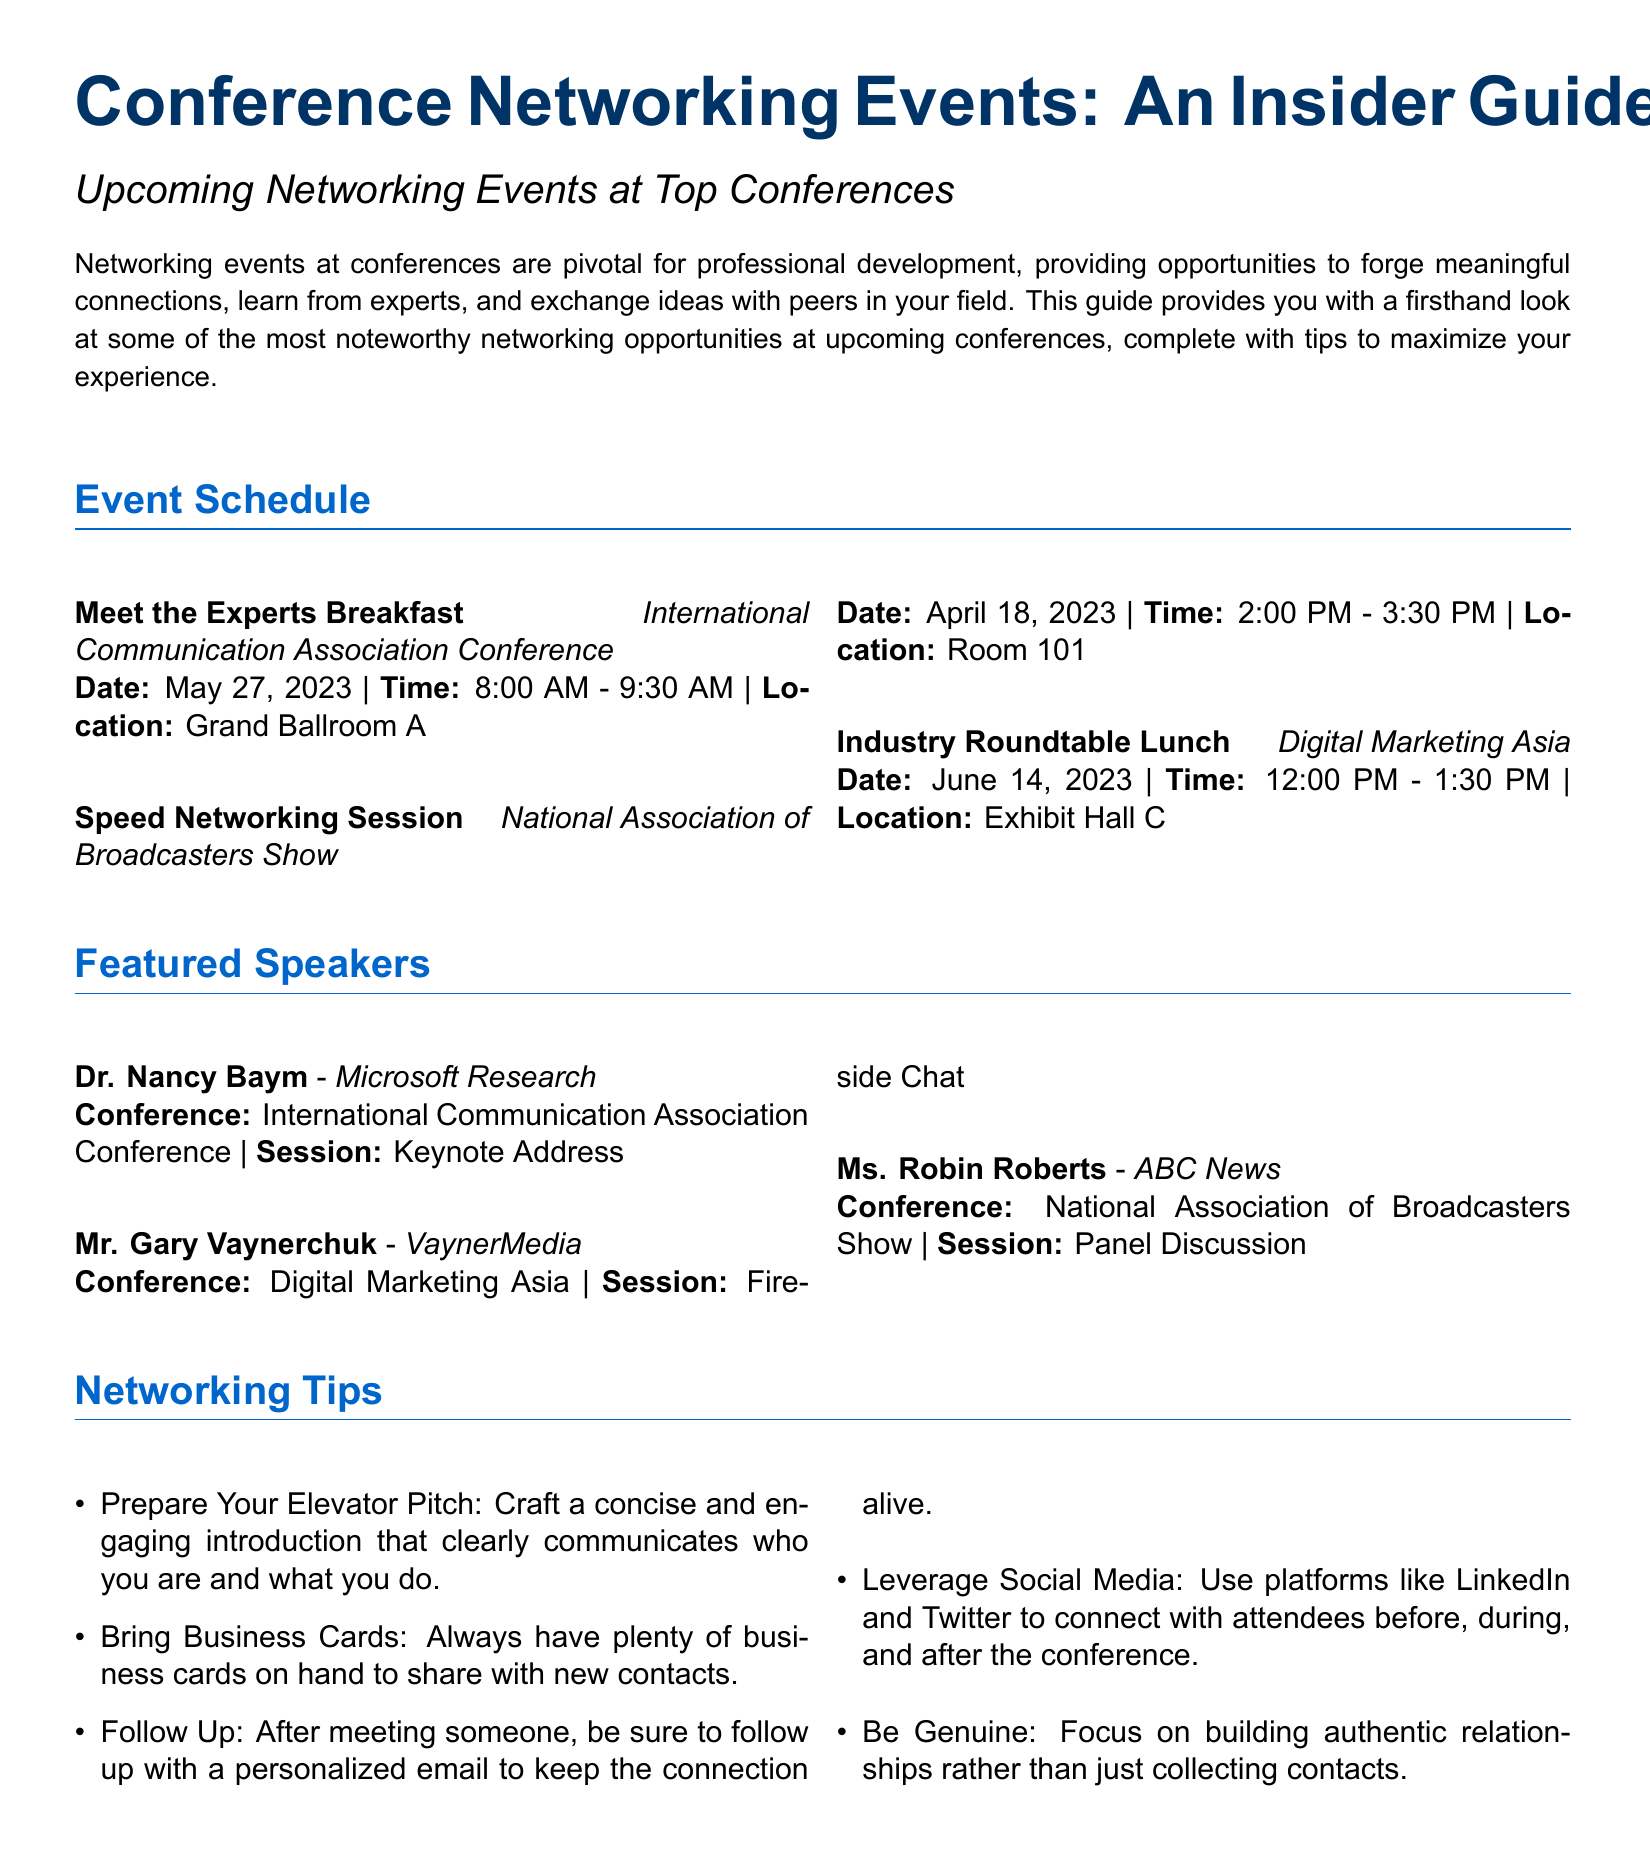What is the date of the Meet the Experts Breakfast? The date for the event is specifically mentioned in the event schedule section of the document.
Answer: May 27, 2023 What is the time for the Speed Networking Session? The document lists the specific time for this event under the event schedule.
Answer: 2:00 PM - 3:30 PM Who is speaking at the Keynote Address? The featured speakers section lists the key note speaker for the International Communication Association Conference.
Answer: Dr. Nancy Baym What type of event is scheduled on June 14, 2023? The document specifies the type of event connected to the provided date in the event schedule.
Answer: Industry Roundtable Lunch Which conference features Mr. Gary Vaynerchuk? The speaker item section indicates the conference associated with the featured speaker's name.
Answer: Digital Marketing Asia How many networking tips are listed in the document? The list of networking tips in the document provides clear indicators of the quantity.
Answer: Five What is a recommended action after meeting someone? The networking tips section outlines following up as a suggested action after a new encounter.
Answer: Follow Up What is the color used for the section titles? The document describes specific colors used for formatting, particularly the section color.
Answer: RGB(0,102,204) 